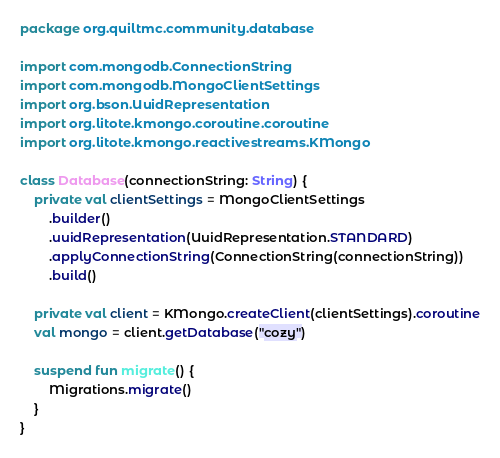<code> <loc_0><loc_0><loc_500><loc_500><_Kotlin_>package org.quiltmc.community.database

import com.mongodb.ConnectionString
import com.mongodb.MongoClientSettings
import org.bson.UuidRepresentation
import org.litote.kmongo.coroutine.coroutine
import org.litote.kmongo.reactivestreams.KMongo

class Database(connectionString: String) {
    private val clientSettings = MongoClientSettings
        .builder()
        .uuidRepresentation(UuidRepresentation.STANDARD)
        .applyConnectionString(ConnectionString(connectionString))
        .build()

    private val client = KMongo.createClient(clientSettings).coroutine
    val mongo = client.getDatabase("cozy")

    suspend fun migrate() {
        Migrations.migrate()
    }
}
</code> 